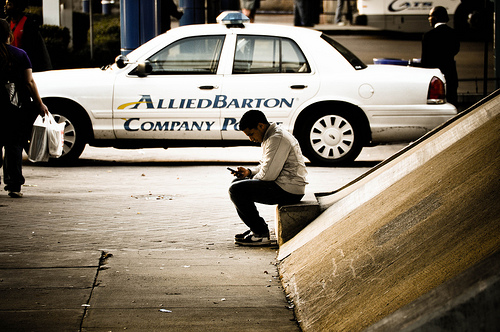Which side is the paper bag on? The paper bag is on the left side of the image, next to the man who is sitting and looking at his phone. 